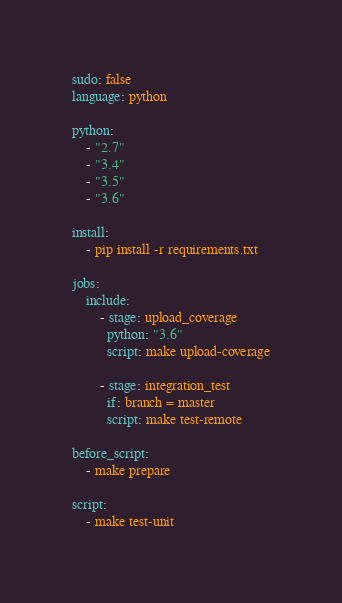<code> <loc_0><loc_0><loc_500><loc_500><_YAML_>sudo: false
language: python

python:
    - "2.7"
    - "3.4"
    - "3.5"
    - "3.6"

install:
    - pip install -r requirements.txt

jobs:
    include:
        - stage: upload_coverage
          python: "3.6"
          script: make upload-coverage

        - stage: integration_test
          if: branch = master
          script: make test-remote

before_script:
    - make prepare

script:
    - make test-unit
</code> 